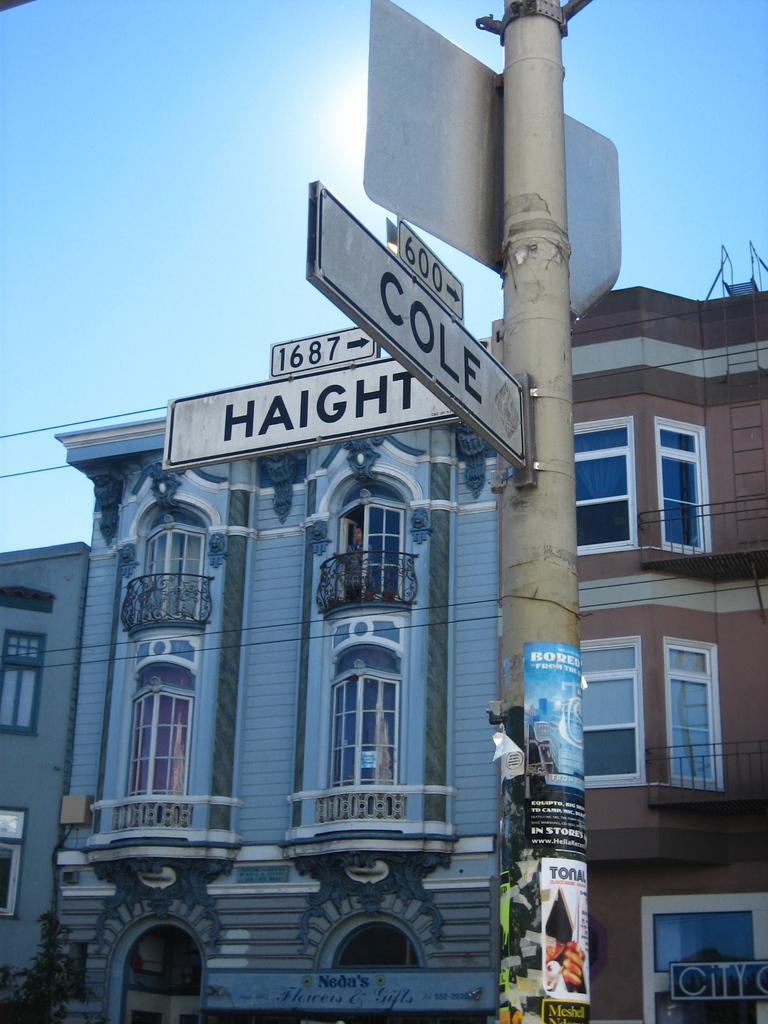Could you give a brief overview of what you see in this image? In this image, there are a few buildings. We can see some boards with text. We can also see a pole with some posters. There are a few boards with text attached to the pole. We can see some wires and the sky. 